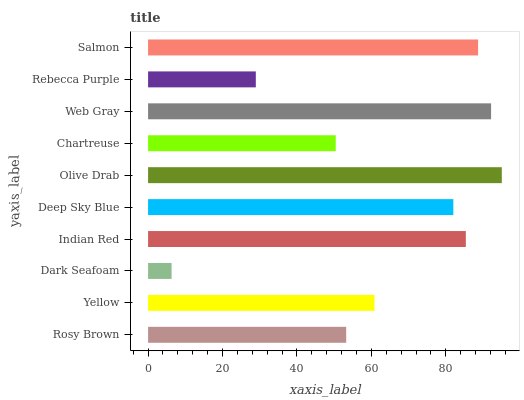Is Dark Seafoam the minimum?
Answer yes or no. Yes. Is Olive Drab the maximum?
Answer yes or no. Yes. Is Yellow the minimum?
Answer yes or no. No. Is Yellow the maximum?
Answer yes or no. No. Is Yellow greater than Rosy Brown?
Answer yes or no. Yes. Is Rosy Brown less than Yellow?
Answer yes or no. Yes. Is Rosy Brown greater than Yellow?
Answer yes or no. No. Is Yellow less than Rosy Brown?
Answer yes or no. No. Is Deep Sky Blue the high median?
Answer yes or no. Yes. Is Yellow the low median?
Answer yes or no. Yes. Is Indian Red the high median?
Answer yes or no. No. Is Salmon the low median?
Answer yes or no. No. 